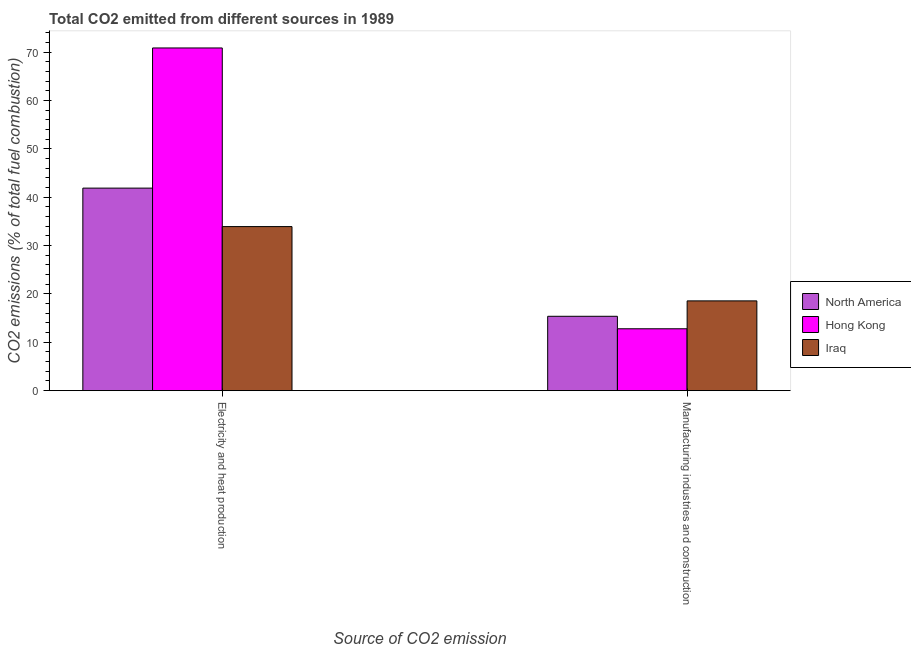Are the number of bars per tick equal to the number of legend labels?
Your answer should be compact. Yes. How many bars are there on the 1st tick from the right?
Provide a succinct answer. 3. What is the label of the 1st group of bars from the left?
Your answer should be very brief. Electricity and heat production. What is the co2 emissions due to manufacturing industries in Iraq?
Give a very brief answer. 18.56. Across all countries, what is the maximum co2 emissions due to electricity and heat production?
Provide a succinct answer. 70.85. Across all countries, what is the minimum co2 emissions due to electricity and heat production?
Provide a short and direct response. 33.92. In which country was the co2 emissions due to electricity and heat production maximum?
Give a very brief answer. Hong Kong. In which country was the co2 emissions due to electricity and heat production minimum?
Your response must be concise. Iraq. What is the total co2 emissions due to electricity and heat production in the graph?
Offer a very short reply. 146.64. What is the difference between the co2 emissions due to manufacturing industries in North America and that in Iraq?
Your answer should be very brief. -3.18. What is the difference between the co2 emissions due to manufacturing industries in Hong Kong and the co2 emissions due to electricity and heat production in North America?
Keep it short and to the point. -29.08. What is the average co2 emissions due to electricity and heat production per country?
Give a very brief answer. 48.88. What is the difference between the co2 emissions due to manufacturing industries and co2 emissions due to electricity and heat production in Hong Kong?
Provide a short and direct response. -58.05. In how many countries, is the co2 emissions due to manufacturing industries greater than 24 %?
Offer a very short reply. 0. What is the ratio of the co2 emissions due to electricity and heat production in Iraq to that in Hong Kong?
Your answer should be very brief. 0.48. What does the 3rd bar from the left in Manufacturing industries and construction represents?
Provide a short and direct response. Iraq. What does the 3rd bar from the right in Electricity and heat production represents?
Offer a terse response. North America. How many bars are there?
Offer a terse response. 6. Are all the bars in the graph horizontal?
Keep it short and to the point. No. How many countries are there in the graph?
Your response must be concise. 3. Are the values on the major ticks of Y-axis written in scientific E-notation?
Offer a very short reply. No. How many legend labels are there?
Make the answer very short. 3. How are the legend labels stacked?
Give a very brief answer. Vertical. What is the title of the graph?
Provide a succinct answer. Total CO2 emitted from different sources in 1989. What is the label or title of the X-axis?
Offer a very short reply. Source of CO2 emission. What is the label or title of the Y-axis?
Give a very brief answer. CO2 emissions (% of total fuel combustion). What is the CO2 emissions (% of total fuel combustion) of North America in Electricity and heat production?
Your response must be concise. 41.87. What is the CO2 emissions (% of total fuel combustion) of Hong Kong in Electricity and heat production?
Offer a very short reply. 70.85. What is the CO2 emissions (% of total fuel combustion) of Iraq in Electricity and heat production?
Offer a very short reply. 33.92. What is the CO2 emissions (% of total fuel combustion) of North America in Manufacturing industries and construction?
Your response must be concise. 15.37. What is the CO2 emissions (% of total fuel combustion) in Hong Kong in Manufacturing industries and construction?
Make the answer very short. 12.79. What is the CO2 emissions (% of total fuel combustion) of Iraq in Manufacturing industries and construction?
Keep it short and to the point. 18.56. Across all Source of CO2 emission, what is the maximum CO2 emissions (% of total fuel combustion) of North America?
Make the answer very short. 41.87. Across all Source of CO2 emission, what is the maximum CO2 emissions (% of total fuel combustion) of Hong Kong?
Keep it short and to the point. 70.85. Across all Source of CO2 emission, what is the maximum CO2 emissions (% of total fuel combustion) of Iraq?
Provide a short and direct response. 33.92. Across all Source of CO2 emission, what is the minimum CO2 emissions (% of total fuel combustion) of North America?
Provide a short and direct response. 15.37. Across all Source of CO2 emission, what is the minimum CO2 emissions (% of total fuel combustion) in Hong Kong?
Give a very brief answer. 12.79. Across all Source of CO2 emission, what is the minimum CO2 emissions (% of total fuel combustion) in Iraq?
Offer a terse response. 18.56. What is the total CO2 emissions (% of total fuel combustion) of North America in the graph?
Your response must be concise. 57.25. What is the total CO2 emissions (% of total fuel combustion) of Hong Kong in the graph?
Your response must be concise. 83.64. What is the total CO2 emissions (% of total fuel combustion) of Iraq in the graph?
Your response must be concise. 52.48. What is the difference between the CO2 emissions (% of total fuel combustion) of North America in Electricity and heat production and that in Manufacturing industries and construction?
Provide a short and direct response. 26.5. What is the difference between the CO2 emissions (% of total fuel combustion) in Hong Kong in Electricity and heat production and that in Manufacturing industries and construction?
Give a very brief answer. 58.05. What is the difference between the CO2 emissions (% of total fuel combustion) of Iraq in Electricity and heat production and that in Manufacturing industries and construction?
Your answer should be compact. 15.36. What is the difference between the CO2 emissions (% of total fuel combustion) in North America in Electricity and heat production and the CO2 emissions (% of total fuel combustion) in Hong Kong in Manufacturing industries and construction?
Provide a short and direct response. 29.08. What is the difference between the CO2 emissions (% of total fuel combustion) of North America in Electricity and heat production and the CO2 emissions (% of total fuel combustion) of Iraq in Manufacturing industries and construction?
Your response must be concise. 23.31. What is the difference between the CO2 emissions (% of total fuel combustion) in Hong Kong in Electricity and heat production and the CO2 emissions (% of total fuel combustion) in Iraq in Manufacturing industries and construction?
Your answer should be very brief. 52.29. What is the average CO2 emissions (% of total fuel combustion) in North America per Source of CO2 emission?
Your answer should be compact. 28.62. What is the average CO2 emissions (% of total fuel combustion) of Hong Kong per Source of CO2 emission?
Your response must be concise. 41.82. What is the average CO2 emissions (% of total fuel combustion) of Iraq per Source of CO2 emission?
Give a very brief answer. 26.24. What is the difference between the CO2 emissions (% of total fuel combustion) of North America and CO2 emissions (% of total fuel combustion) of Hong Kong in Electricity and heat production?
Your response must be concise. -28.98. What is the difference between the CO2 emissions (% of total fuel combustion) of North America and CO2 emissions (% of total fuel combustion) of Iraq in Electricity and heat production?
Ensure brevity in your answer.  7.95. What is the difference between the CO2 emissions (% of total fuel combustion) in Hong Kong and CO2 emissions (% of total fuel combustion) in Iraq in Electricity and heat production?
Provide a succinct answer. 36.93. What is the difference between the CO2 emissions (% of total fuel combustion) of North America and CO2 emissions (% of total fuel combustion) of Hong Kong in Manufacturing industries and construction?
Offer a very short reply. 2.58. What is the difference between the CO2 emissions (% of total fuel combustion) of North America and CO2 emissions (% of total fuel combustion) of Iraq in Manufacturing industries and construction?
Your answer should be very brief. -3.18. What is the difference between the CO2 emissions (% of total fuel combustion) in Hong Kong and CO2 emissions (% of total fuel combustion) in Iraq in Manufacturing industries and construction?
Offer a terse response. -5.76. What is the ratio of the CO2 emissions (% of total fuel combustion) of North America in Electricity and heat production to that in Manufacturing industries and construction?
Ensure brevity in your answer.  2.72. What is the ratio of the CO2 emissions (% of total fuel combustion) in Hong Kong in Electricity and heat production to that in Manufacturing industries and construction?
Your answer should be compact. 5.54. What is the ratio of the CO2 emissions (% of total fuel combustion) in Iraq in Electricity and heat production to that in Manufacturing industries and construction?
Keep it short and to the point. 1.83. What is the difference between the highest and the second highest CO2 emissions (% of total fuel combustion) of North America?
Your answer should be very brief. 26.5. What is the difference between the highest and the second highest CO2 emissions (% of total fuel combustion) in Hong Kong?
Ensure brevity in your answer.  58.05. What is the difference between the highest and the second highest CO2 emissions (% of total fuel combustion) of Iraq?
Provide a short and direct response. 15.36. What is the difference between the highest and the lowest CO2 emissions (% of total fuel combustion) in North America?
Ensure brevity in your answer.  26.5. What is the difference between the highest and the lowest CO2 emissions (% of total fuel combustion) in Hong Kong?
Provide a succinct answer. 58.05. What is the difference between the highest and the lowest CO2 emissions (% of total fuel combustion) in Iraq?
Keep it short and to the point. 15.36. 